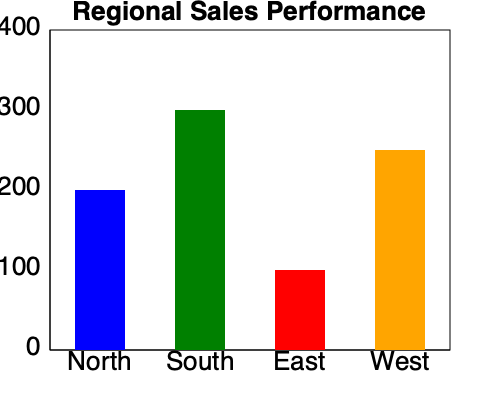Based on the bar graph showing regional sales performance, which region has the highest sales, and what is the difference in sales between the top-performing region and the lowest-performing region? To answer this question, we need to analyze the bar graph and follow these steps:

1. Identify the highest bar:
   The green bar representing the South region is the tallest, reaching just above the 300 mark.

2. Identify the lowest bar:
   The red bar representing the East region is the shortest, reaching just below the 100 mark.

3. Estimate the values:
   South (green): Approximately 350 units
   East (red): Approximately 80 units

4. Calculate the difference:
   Difference = South's sales - East's sales
               ≈ 350 - 80
               = 270 units

Therefore, the South region has the highest sales, and the difference in sales between the top-performing region (South) and the lowest-performing region (East) is approximately 270 units.
Answer: South; 270 units 